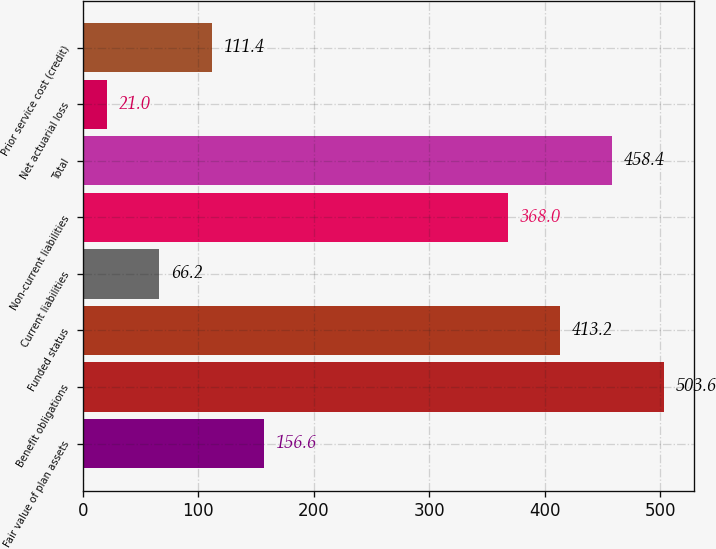<chart> <loc_0><loc_0><loc_500><loc_500><bar_chart><fcel>Fair value of plan assets<fcel>Benefit obligations<fcel>Funded status<fcel>Current liabilities<fcel>Non-current liabilities<fcel>Total<fcel>Net actuarial loss<fcel>Prior service cost (credit)<nl><fcel>156.6<fcel>503.6<fcel>413.2<fcel>66.2<fcel>368<fcel>458.4<fcel>21<fcel>111.4<nl></chart> 